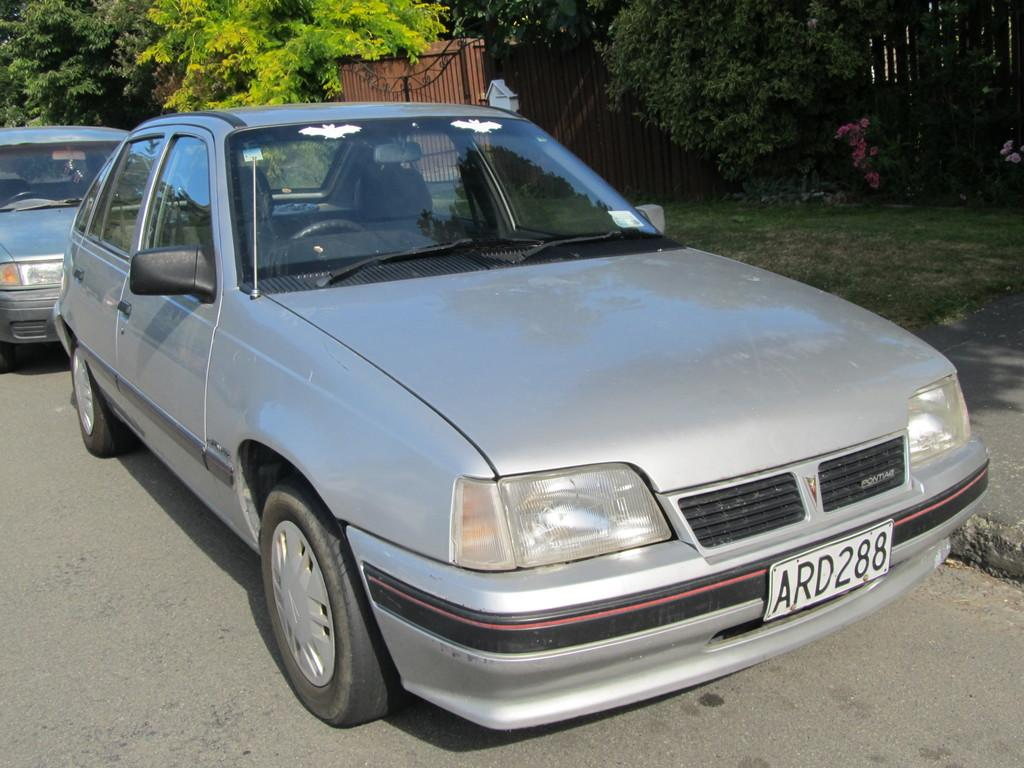Where was the image taken? The image is clicked outside. What can be seen in the middle of the image? There are cars in the middle of the image. What color are the cars? The cars are gray in color. What is visible at the top of the image? There are trees and a gate at the top of the image. What type of fowl can be seen causing a disturbance in the image? There is no fowl present in the image, nor is there any disturbance caused by any animal. In which month was the image taken? The provided facts do not mention the month in which the image was taken. 